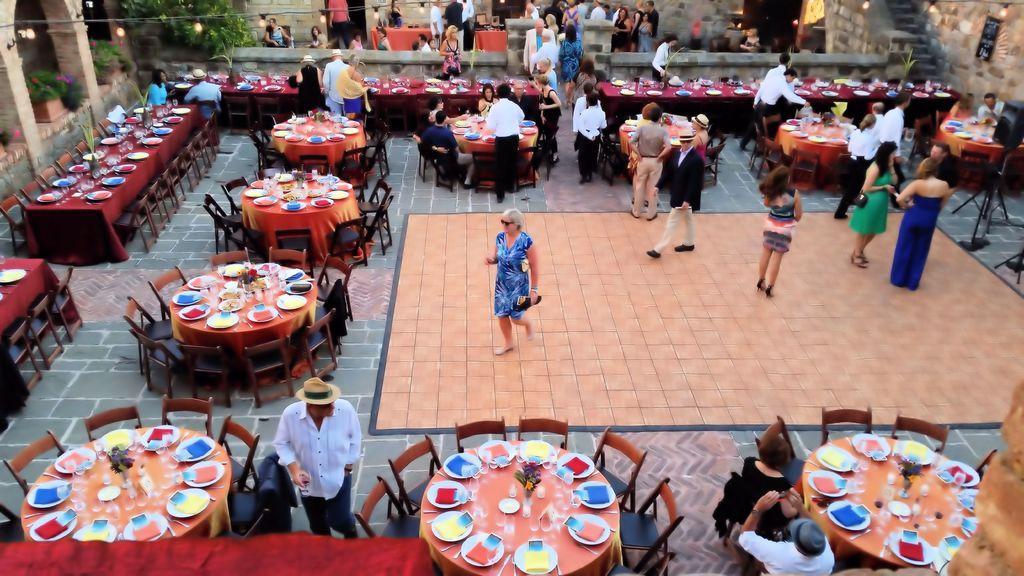Could you give a brief overview of what you see in this image? This is an outside area. In this image I can see few people are standing and few people are sitting on the chairs around the table and here we can see some dining tables are arranged. In the background there is a wall and trees. 